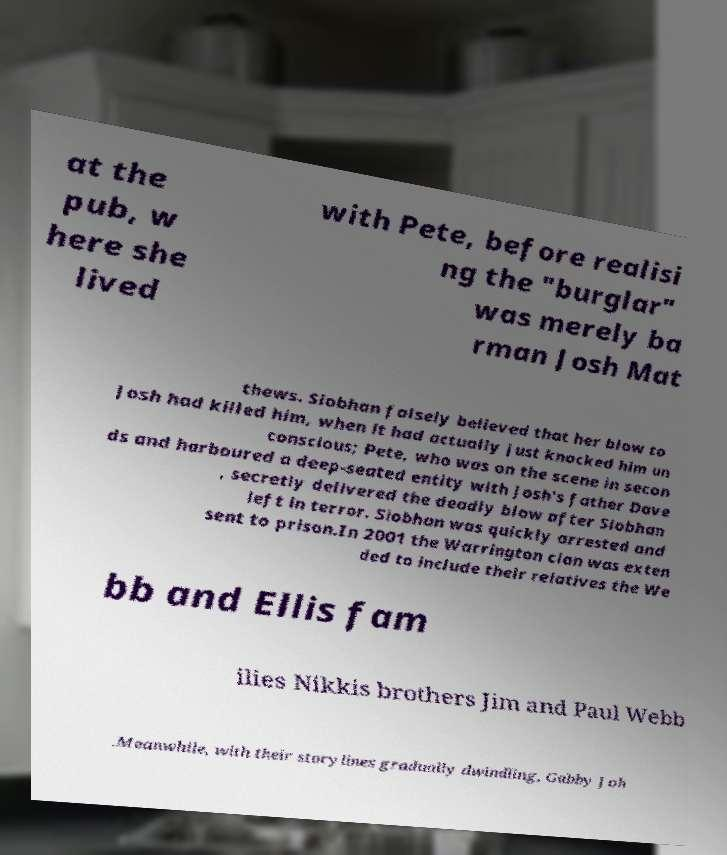Please identify and transcribe the text found in this image. at the pub, w here she lived with Pete, before realisi ng the "burglar" was merely ba rman Josh Mat thews. Siobhan falsely believed that her blow to Josh had killed him, when it had actually just knocked him un conscious; Pete, who was on the scene in secon ds and harboured a deep-seated entity with Josh's father Dave , secretly delivered the deadly blow after Siobhan left in terror. Siobhan was quickly arrested and sent to prison.In 2001 the Warrington clan was exten ded to include their relatives the We bb and Ellis fam ilies Nikkis brothers Jim and Paul Webb .Meanwhile, with their storylines gradually dwindling, Gabby Joh 